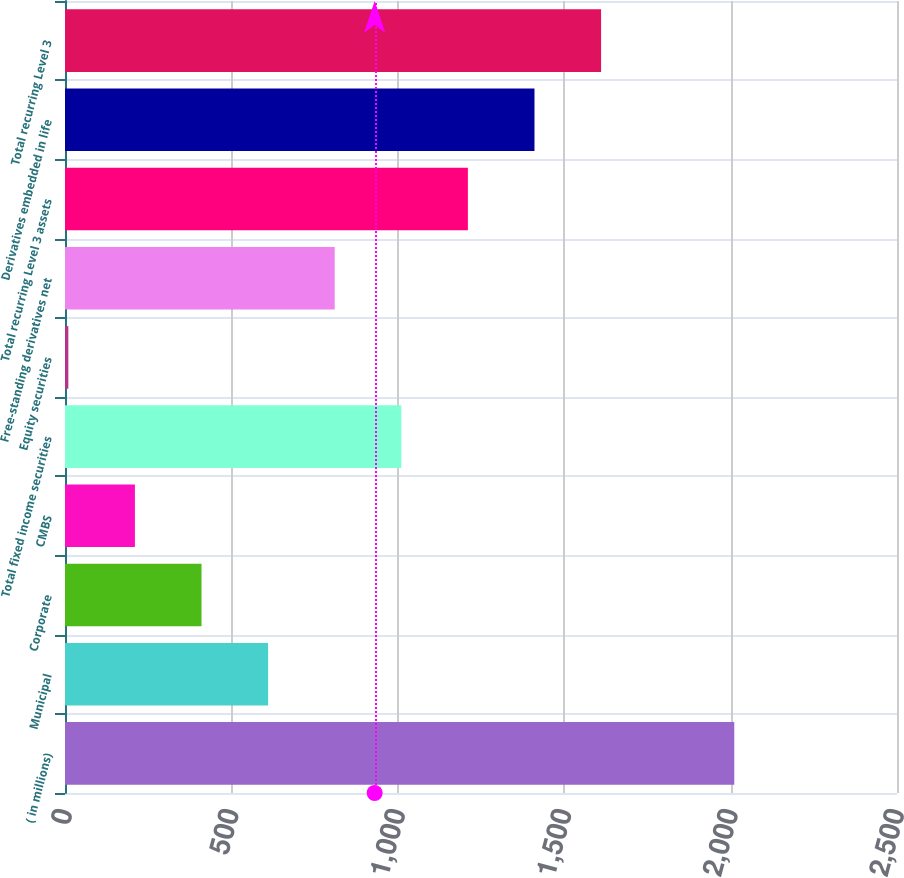<chart> <loc_0><loc_0><loc_500><loc_500><bar_chart><fcel>( in millions)<fcel>Municipal<fcel>Corporate<fcel>CMBS<fcel>Total fixed income securities<fcel>Equity securities<fcel>Free-standing derivatives net<fcel>Total recurring Level 3 assets<fcel>Derivatives embedded in life<fcel>Total recurring Level 3<nl><fcel>2011<fcel>610.3<fcel>410.2<fcel>210.1<fcel>1010.5<fcel>10<fcel>810.4<fcel>1210.6<fcel>1410.7<fcel>1610.8<nl></chart> 